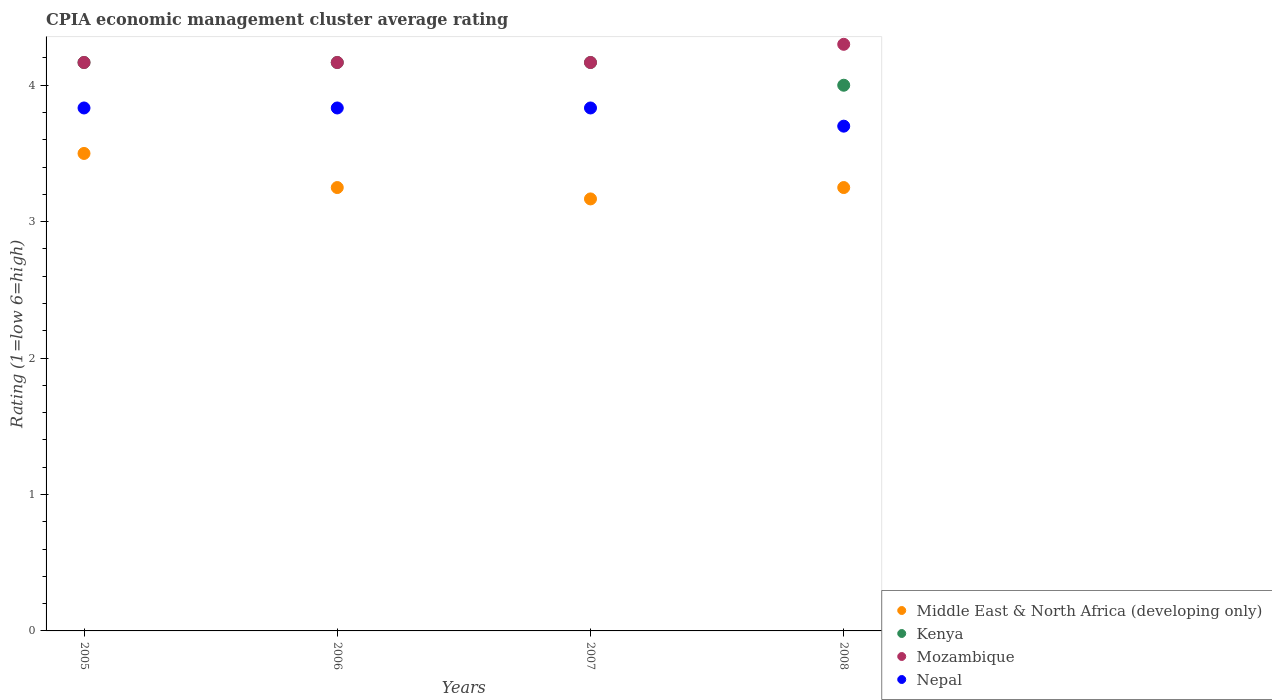How many different coloured dotlines are there?
Provide a short and direct response. 4. What is the CPIA rating in Mozambique in 2005?
Provide a short and direct response. 4.17. Across all years, what is the maximum CPIA rating in Nepal?
Provide a succinct answer. 3.83. Across all years, what is the minimum CPIA rating in Mozambique?
Offer a very short reply. 4.17. In which year was the CPIA rating in Kenya maximum?
Provide a succinct answer. 2005. What is the total CPIA rating in Nepal in the graph?
Give a very brief answer. 15.2. What is the difference between the CPIA rating in Middle East & North Africa (developing only) in 2006 and that in 2007?
Ensure brevity in your answer.  0.08. What is the difference between the CPIA rating in Middle East & North Africa (developing only) in 2006 and the CPIA rating in Mozambique in 2005?
Give a very brief answer. -0.92. What is the average CPIA rating in Kenya per year?
Offer a very short reply. 4.13. In the year 2008, what is the difference between the CPIA rating in Mozambique and CPIA rating in Middle East & North Africa (developing only)?
Your response must be concise. 1.05. What is the ratio of the CPIA rating in Mozambique in 2005 to that in 2008?
Provide a short and direct response. 0.97. Is the CPIA rating in Kenya in 2007 less than that in 2008?
Give a very brief answer. No. Is the difference between the CPIA rating in Mozambique in 2006 and 2007 greater than the difference between the CPIA rating in Middle East & North Africa (developing only) in 2006 and 2007?
Offer a very short reply. No. What is the difference between the highest and the second highest CPIA rating in Middle East & North Africa (developing only)?
Make the answer very short. 0.25. What is the difference between the highest and the lowest CPIA rating in Nepal?
Provide a succinct answer. 0.13. Is the sum of the CPIA rating in Mozambique in 2006 and 2008 greater than the maximum CPIA rating in Middle East & North Africa (developing only) across all years?
Your answer should be very brief. Yes. Is it the case that in every year, the sum of the CPIA rating in Kenya and CPIA rating in Nepal  is greater than the CPIA rating in Middle East & North Africa (developing only)?
Provide a short and direct response. Yes. Is the CPIA rating in Middle East & North Africa (developing only) strictly greater than the CPIA rating in Nepal over the years?
Make the answer very short. No. How many dotlines are there?
Offer a terse response. 4. How many years are there in the graph?
Offer a terse response. 4. What is the difference between two consecutive major ticks on the Y-axis?
Offer a very short reply. 1. Does the graph contain any zero values?
Your answer should be compact. No. Does the graph contain grids?
Offer a terse response. No. How many legend labels are there?
Your response must be concise. 4. What is the title of the graph?
Give a very brief answer. CPIA economic management cluster average rating. Does "South Sudan" appear as one of the legend labels in the graph?
Your answer should be compact. No. What is the label or title of the Y-axis?
Give a very brief answer. Rating (1=low 6=high). What is the Rating (1=low 6=high) of Kenya in 2005?
Your answer should be very brief. 4.17. What is the Rating (1=low 6=high) of Mozambique in 2005?
Keep it short and to the point. 4.17. What is the Rating (1=low 6=high) of Nepal in 2005?
Offer a very short reply. 3.83. What is the Rating (1=low 6=high) in Kenya in 2006?
Provide a succinct answer. 4.17. What is the Rating (1=low 6=high) of Mozambique in 2006?
Give a very brief answer. 4.17. What is the Rating (1=low 6=high) of Nepal in 2006?
Provide a succinct answer. 3.83. What is the Rating (1=low 6=high) of Middle East & North Africa (developing only) in 2007?
Offer a very short reply. 3.17. What is the Rating (1=low 6=high) in Kenya in 2007?
Provide a succinct answer. 4.17. What is the Rating (1=low 6=high) of Mozambique in 2007?
Your answer should be compact. 4.17. What is the Rating (1=low 6=high) in Nepal in 2007?
Give a very brief answer. 3.83. What is the Rating (1=low 6=high) in Middle East & North Africa (developing only) in 2008?
Your answer should be compact. 3.25. What is the Rating (1=low 6=high) in Mozambique in 2008?
Give a very brief answer. 4.3. Across all years, what is the maximum Rating (1=low 6=high) of Kenya?
Your answer should be very brief. 4.17. Across all years, what is the maximum Rating (1=low 6=high) in Nepal?
Offer a terse response. 3.83. Across all years, what is the minimum Rating (1=low 6=high) of Middle East & North Africa (developing only)?
Provide a short and direct response. 3.17. Across all years, what is the minimum Rating (1=low 6=high) of Mozambique?
Ensure brevity in your answer.  4.17. What is the total Rating (1=low 6=high) of Middle East & North Africa (developing only) in the graph?
Provide a short and direct response. 13.17. What is the difference between the Rating (1=low 6=high) in Middle East & North Africa (developing only) in 2005 and that in 2006?
Make the answer very short. 0.25. What is the difference between the Rating (1=low 6=high) of Mozambique in 2005 and that in 2006?
Ensure brevity in your answer.  0. What is the difference between the Rating (1=low 6=high) in Middle East & North Africa (developing only) in 2005 and that in 2007?
Offer a terse response. 0.33. What is the difference between the Rating (1=low 6=high) of Mozambique in 2005 and that in 2008?
Keep it short and to the point. -0.13. What is the difference between the Rating (1=low 6=high) of Nepal in 2005 and that in 2008?
Give a very brief answer. 0.13. What is the difference between the Rating (1=low 6=high) of Middle East & North Africa (developing only) in 2006 and that in 2007?
Keep it short and to the point. 0.08. What is the difference between the Rating (1=low 6=high) in Mozambique in 2006 and that in 2007?
Your answer should be compact. 0. What is the difference between the Rating (1=low 6=high) in Nepal in 2006 and that in 2007?
Keep it short and to the point. 0. What is the difference between the Rating (1=low 6=high) in Kenya in 2006 and that in 2008?
Provide a short and direct response. 0.17. What is the difference between the Rating (1=low 6=high) of Mozambique in 2006 and that in 2008?
Your answer should be compact. -0.13. What is the difference between the Rating (1=low 6=high) in Nepal in 2006 and that in 2008?
Keep it short and to the point. 0.13. What is the difference between the Rating (1=low 6=high) in Middle East & North Africa (developing only) in 2007 and that in 2008?
Your response must be concise. -0.08. What is the difference between the Rating (1=low 6=high) of Kenya in 2007 and that in 2008?
Your answer should be compact. 0.17. What is the difference between the Rating (1=low 6=high) of Mozambique in 2007 and that in 2008?
Keep it short and to the point. -0.13. What is the difference between the Rating (1=low 6=high) of Nepal in 2007 and that in 2008?
Make the answer very short. 0.13. What is the difference between the Rating (1=low 6=high) of Kenya in 2005 and the Rating (1=low 6=high) of Mozambique in 2006?
Offer a very short reply. 0. What is the difference between the Rating (1=low 6=high) of Middle East & North Africa (developing only) in 2005 and the Rating (1=low 6=high) of Nepal in 2007?
Your answer should be compact. -0.33. What is the difference between the Rating (1=low 6=high) of Kenya in 2005 and the Rating (1=low 6=high) of Mozambique in 2007?
Ensure brevity in your answer.  0. What is the difference between the Rating (1=low 6=high) of Mozambique in 2005 and the Rating (1=low 6=high) of Nepal in 2007?
Your response must be concise. 0.33. What is the difference between the Rating (1=low 6=high) of Middle East & North Africa (developing only) in 2005 and the Rating (1=low 6=high) of Kenya in 2008?
Offer a terse response. -0.5. What is the difference between the Rating (1=low 6=high) of Kenya in 2005 and the Rating (1=low 6=high) of Mozambique in 2008?
Make the answer very short. -0.13. What is the difference between the Rating (1=low 6=high) in Kenya in 2005 and the Rating (1=low 6=high) in Nepal in 2008?
Provide a succinct answer. 0.47. What is the difference between the Rating (1=low 6=high) in Mozambique in 2005 and the Rating (1=low 6=high) in Nepal in 2008?
Provide a succinct answer. 0.47. What is the difference between the Rating (1=low 6=high) in Middle East & North Africa (developing only) in 2006 and the Rating (1=low 6=high) in Kenya in 2007?
Offer a terse response. -0.92. What is the difference between the Rating (1=low 6=high) of Middle East & North Africa (developing only) in 2006 and the Rating (1=low 6=high) of Mozambique in 2007?
Provide a succinct answer. -0.92. What is the difference between the Rating (1=low 6=high) of Middle East & North Africa (developing only) in 2006 and the Rating (1=low 6=high) of Nepal in 2007?
Give a very brief answer. -0.58. What is the difference between the Rating (1=low 6=high) of Kenya in 2006 and the Rating (1=low 6=high) of Mozambique in 2007?
Provide a succinct answer. 0. What is the difference between the Rating (1=low 6=high) in Mozambique in 2006 and the Rating (1=low 6=high) in Nepal in 2007?
Offer a terse response. 0.33. What is the difference between the Rating (1=low 6=high) of Middle East & North Africa (developing only) in 2006 and the Rating (1=low 6=high) of Kenya in 2008?
Offer a terse response. -0.75. What is the difference between the Rating (1=low 6=high) in Middle East & North Africa (developing only) in 2006 and the Rating (1=low 6=high) in Mozambique in 2008?
Give a very brief answer. -1.05. What is the difference between the Rating (1=low 6=high) of Middle East & North Africa (developing only) in 2006 and the Rating (1=low 6=high) of Nepal in 2008?
Your answer should be very brief. -0.45. What is the difference between the Rating (1=low 6=high) in Kenya in 2006 and the Rating (1=low 6=high) in Mozambique in 2008?
Offer a terse response. -0.13. What is the difference between the Rating (1=low 6=high) of Kenya in 2006 and the Rating (1=low 6=high) of Nepal in 2008?
Provide a succinct answer. 0.47. What is the difference between the Rating (1=low 6=high) of Mozambique in 2006 and the Rating (1=low 6=high) of Nepal in 2008?
Provide a short and direct response. 0.47. What is the difference between the Rating (1=low 6=high) of Middle East & North Africa (developing only) in 2007 and the Rating (1=low 6=high) of Kenya in 2008?
Your response must be concise. -0.83. What is the difference between the Rating (1=low 6=high) in Middle East & North Africa (developing only) in 2007 and the Rating (1=low 6=high) in Mozambique in 2008?
Provide a succinct answer. -1.13. What is the difference between the Rating (1=low 6=high) in Middle East & North Africa (developing only) in 2007 and the Rating (1=low 6=high) in Nepal in 2008?
Offer a terse response. -0.53. What is the difference between the Rating (1=low 6=high) in Kenya in 2007 and the Rating (1=low 6=high) in Mozambique in 2008?
Offer a terse response. -0.13. What is the difference between the Rating (1=low 6=high) of Kenya in 2007 and the Rating (1=low 6=high) of Nepal in 2008?
Give a very brief answer. 0.47. What is the difference between the Rating (1=low 6=high) of Mozambique in 2007 and the Rating (1=low 6=high) of Nepal in 2008?
Your response must be concise. 0.47. What is the average Rating (1=low 6=high) of Middle East & North Africa (developing only) per year?
Provide a short and direct response. 3.29. What is the average Rating (1=low 6=high) in Kenya per year?
Give a very brief answer. 4.12. In the year 2005, what is the difference between the Rating (1=low 6=high) in Middle East & North Africa (developing only) and Rating (1=low 6=high) in Kenya?
Offer a terse response. -0.67. In the year 2005, what is the difference between the Rating (1=low 6=high) in Middle East & North Africa (developing only) and Rating (1=low 6=high) in Mozambique?
Keep it short and to the point. -0.67. In the year 2005, what is the difference between the Rating (1=low 6=high) in Kenya and Rating (1=low 6=high) in Mozambique?
Make the answer very short. 0. In the year 2005, what is the difference between the Rating (1=low 6=high) of Mozambique and Rating (1=low 6=high) of Nepal?
Offer a very short reply. 0.33. In the year 2006, what is the difference between the Rating (1=low 6=high) in Middle East & North Africa (developing only) and Rating (1=low 6=high) in Kenya?
Your answer should be very brief. -0.92. In the year 2006, what is the difference between the Rating (1=low 6=high) of Middle East & North Africa (developing only) and Rating (1=low 6=high) of Mozambique?
Your answer should be very brief. -0.92. In the year 2006, what is the difference between the Rating (1=low 6=high) in Middle East & North Africa (developing only) and Rating (1=low 6=high) in Nepal?
Provide a short and direct response. -0.58. In the year 2006, what is the difference between the Rating (1=low 6=high) in Kenya and Rating (1=low 6=high) in Nepal?
Offer a very short reply. 0.33. In the year 2007, what is the difference between the Rating (1=low 6=high) of Middle East & North Africa (developing only) and Rating (1=low 6=high) of Mozambique?
Offer a terse response. -1. In the year 2007, what is the difference between the Rating (1=low 6=high) in Middle East & North Africa (developing only) and Rating (1=low 6=high) in Nepal?
Give a very brief answer. -0.67. In the year 2007, what is the difference between the Rating (1=low 6=high) in Mozambique and Rating (1=low 6=high) in Nepal?
Provide a succinct answer. 0.33. In the year 2008, what is the difference between the Rating (1=low 6=high) of Middle East & North Africa (developing only) and Rating (1=low 6=high) of Kenya?
Keep it short and to the point. -0.75. In the year 2008, what is the difference between the Rating (1=low 6=high) of Middle East & North Africa (developing only) and Rating (1=low 6=high) of Mozambique?
Offer a very short reply. -1.05. In the year 2008, what is the difference between the Rating (1=low 6=high) of Middle East & North Africa (developing only) and Rating (1=low 6=high) of Nepal?
Provide a short and direct response. -0.45. In the year 2008, what is the difference between the Rating (1=low 6=high) in Mozambique and Rating (1=low 6=high) in Nepal?
Your answer should be compact. 0.6. What is the ratio of the Rating (1=low 6=high) of Middle East & North Africa (developing only) in 2005 to that in 2006?
Offer a very short reply. 1.08. What is the ratio of the Rating (1=low 6=high) in Kenya in 2005 to that in 2006?
Offer a terse response. 1. What is the ratio of the Rating (1=low 6=high) in Middle East & North Africa (developing only) in 2005 to that in 2007?
Make the answer very short. 1.11. What is the ratio of the Rating (1=low 6=high) of Mozambique in 2005 to that in 2007?
Make the answer very short. 1. What is the ratio of the Rating (1=low 6=high) of Kenya in 2005 to that in 2008?
Provide a short and direct response. 1.04. What is the ratio of the Rating (1=low 6=high) in Nepal in 2005 to that in 2008?
Keep it short and to the point. 1.04. What is the ratio of the Rating (1=low 6=high) of Middle East & North Africa (developing only) in 2006 to that in 2007?
Your response must be concise. 1.03. What is the ratio of the Rating (1=low 6=high) in Kenya in 2006 to that in 2007?
Give a very brief answer. 1. What is the ratio of the Rating (1=low 6=high) of Mozambique in 2006 to that in 2007?
Make the answer very short. 1. What is the ratio of the Rating (1=low 6=high) in Nepal in 2006 to that in 2007?
Ensure brevity in your answer.  1. What is the ratio of the Rating (1=low 6=high) of Middle East & North Africa (developing only) in 2006 to that in 2008?
Your answer should be compact. 1. What is the ratio of the Rating (1=low 6=high) of Kenya in 2006 to that in 2008?
Your answer should be compact. 1.04. What is the ratio of the Rating (1=low 6=high) of Nepal in 2006 to that in 2008?
Make the answer very short. 1.04. What is the ratio of the Rating (1=low 6=high) in Middle East & North Africa (developing only) in 2007 to that in 2008?
Offer a terse response. 0.97. What is the ratio of the Rating (1=low 6=high) of Kenya in 2007 to that in 2008?
Offer a very short reply. 1.04. What is the ratio of the Rating (1=low 6=high) of Nepal in 2007 to that in 2008?
Your answer should be very brief. 1.04. What is the difference between the highest and the second highest Rating (1=low 6=high) of Middle East & North Africa (developing only)?
Keep it short and to the point. 0.25. What is the difference between the highest and the second highest Rating (1=low 6=high) of Kenya?
Offer a terse response. 0. What is the difference between the highest and the second highest Rating (1=low 6=high) in Mozambique?
Provide a short and direct response. 0.13. What is the difference between the highest and the second highest Rating (1=low 6=high) in Nepal?
Offer a very short reply. 0. What is the difference between the highest and the lowest Rating (1=low 6=high) of Middle East & North Africa (developing only)?
Your response must be concise. 0.33. What is the difference between the highest and the lowest Rating (1=low 6=high) of Kenya?
Provide a succinct answer. 0.17. What is the difference between the highest and the lowest Rating (1=low 6=high) of Mozambique?
Provide a short and direct response. 0.13. What is the difference between the highest and the lowest Rating (1=low 6=high) of Nepal?
Ensure brevity in your answer.  0.13. 